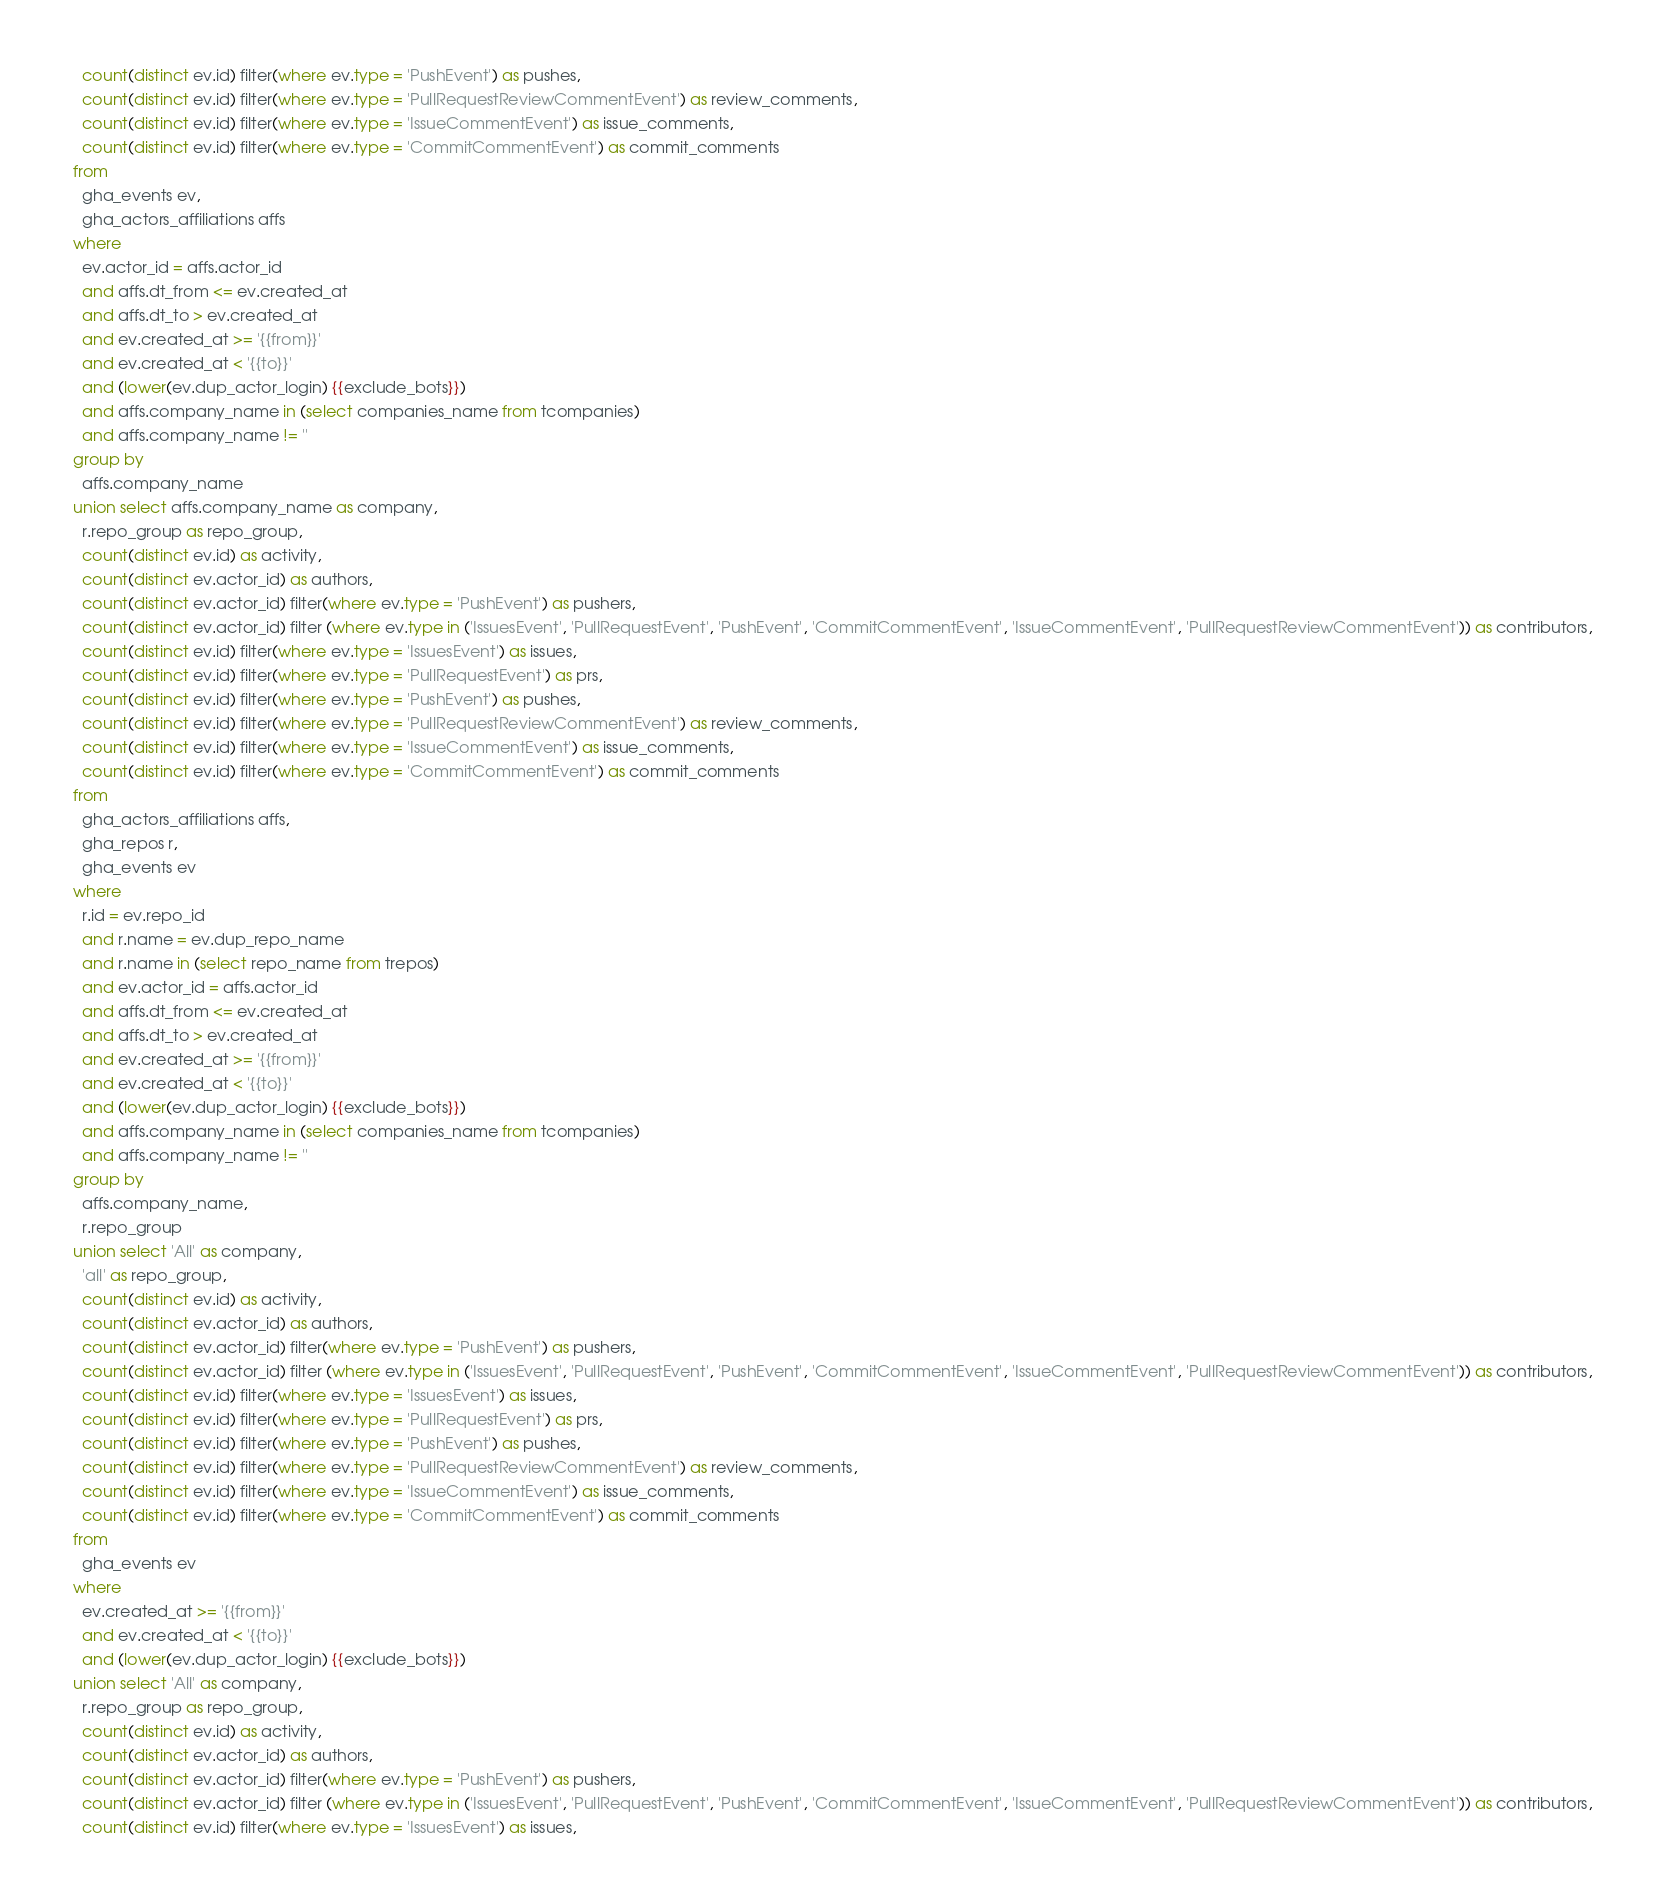Convert code to text. <code><loc_0><loc_0><loc_500><loc_500><_SQL_>    count(distinct ev.id) filter(where ev.type = 'PushEvent') as pushes,
    count(distinct ev.id) filter(where ev.type = 'PullRequestReviewCommentEvent') as review_comments,
    count(distinct ev.id) filter(where ev.type = 'IssueCommentEvent') as issue_comments,
    count(distinct ev.id) filter(where ev.type = 'CommitCommentEvent') as commit_comments
  from
    gha_events ev,
    gha_actors_affiliations affs
  where
    ev.actor_id = affs.actor_id
    and affs.dt_from <= ev.created_at
    and affs.dt_to > ev.created_at
    and ev.created_at >= '{{from}}'
    and ev.created_at < '{{to}}'
    and (lower(ev.dup_actor_login) {{exclude_bots}})
    and affs.company_name in (select companies_name from tcompanies)
    and affs.company_name != ''
  group by
    affs.company_name
  union select affs.company_name as company,
    r.repo_group as repo_group,
    count(distinct ev.id) as activity,
    count(distinct ev.actor_id) as authors,
    count(distinct ev.actor_id) filter(where ev.type = 'PushEvent') as pushers,
    count(distinct ev.actor_id) filter (where ev.type in ('IssuesEvent', 'PullRequestEvent', 'PushEvent', 'CommitCommentEvent', 'IssueCommentEvent', 'PullRequestReviewCommentEvent')) as contributors,
    count(distinct ev.id) filter(where ev.type = 'IssuesEvent') as issues,
    count(distinct ev.id) filter(where ev.type = 'PullRequestEvent') as prs,
    count(distinct ev.id) filter(where ev.type = 'PushEvent') as pushes,
    count(distinct ev.id) filter(where ev.type = 'PullRequestReviewCommentEvent') as review_comments,
    count(distinct ev.id) filter(where ev.type = 'IssueCommentEvent') as issue_comments,
    count(distinct ev.id) filter(where ev.type = 'CommitCommentEvent') as commit_comments
  from
    gha_actors_affiliations affs,
    gha_repos r,
    gha_events ev
  where
    r.id = ev.repo_id
    and r.name = ev.dup_repo_name
    and r.name in (select repo_name from trepos)
    and ev.actor_id = affs.actor_id
    and affs.dt_from <= ev.created_at
    and affs.dt_to > ev.created_at
    and ev.created_at >= '{{from}}'
    and ev.created_at < '{{to}}'
    and (lower(ev.dup_actor_login) {{exclude_bots}})
    and affs.company_name in (select companies_name from tcompanies)
    and affs.company_name != ''
  group by
    affs.company_name,
    r.repo_group
  union select 'All' as company,
    'all' as repo_group,
    count(distinct ev.id) as activity,
    count(distinct ev.actor_id) as authors,
    count(distinct ev.actor_id) filter(where ev.type = 'PushEvent') as pushers,
    count(distinct ev.actor_id) filter (where ev.type in ('IssuesEvent', 'PullRequestEvent', 'PushEvent', 'CommitCommentEvent', 'IssueCommentEvent', 'PullRequestReviewCommentEvent')) as contributors,
    count(distinct ev.id) filter(where ev.type = 'IssuesEvent') as issues,
    count(distinct ev.id) filter(where ev.type = 'PullRequestEvent') as prs,
    count(distinct ev.id) filter(where ev.type = 'PushEvent') as pushes,
    count(distinct ev.id) filter(where ev.type = 'PullRequestReviewCommentEvent') as review_comments,
    count(distinct ev.id) filter(where ev.type = 'IssueCommentEvent') as issue_comments,
    count(distinct ev.id) filter(where ev.type = 'CommitCommentEvent') as commit_comments
  from
    gha_events ev
  where
    ev.created_at >= '{{from}}'
    and ev.created_at < '{{to}}'
    and (lower(ev.dup_actor_login) {{exclude_bots}})
  union select 'All' as company,
    r.repo_group as repo_group,
    count(distinct ev.id) as activity,
    count(distinct ev.actor_id) as authors,
    count(distinct ev.actor_id) filter(where ev.type = 'PushEvent') as pushers,
    count(distinct ev.actor_id) filter (where ev.type in ('IssuesEvent', 'PullRequestEvent', 'PushEvent', 'CommitCommentEvent', 'IssueCommentEvent', 'PullRequestReviewCommentEvent')) as contributors,
    count(distinct ev.id) filter(where ev.type = 'IssuesEvent') as issues,</code> 